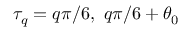Convert formula to latex. <formula><loc_0><loc_0><loc_500><loc_500>\tau _ { q } = q { \pi } / { 6 } , \ q { \pi } / { 6 } + \theta _ { 0 }</formula> 